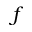<formula> <loc_0><loc_0><loc_500><loc_500>f</formula> 